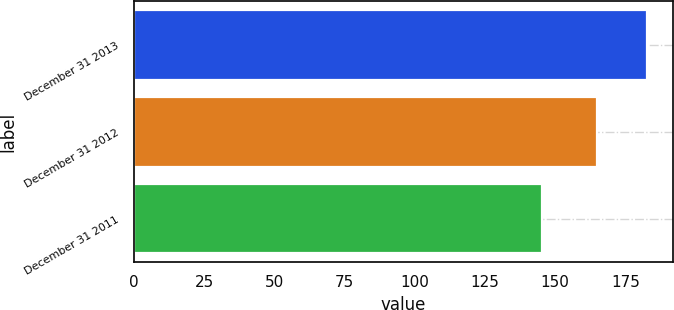<chart> <loc_0><loc_0><loc_500><loc_500><bar_chart><fcel>December 31 2013<fcel>December 31 2012<fcel>December 31 2011<nl><fcel>182.7<fcel>165<fcel>145.4<nl></chart> 